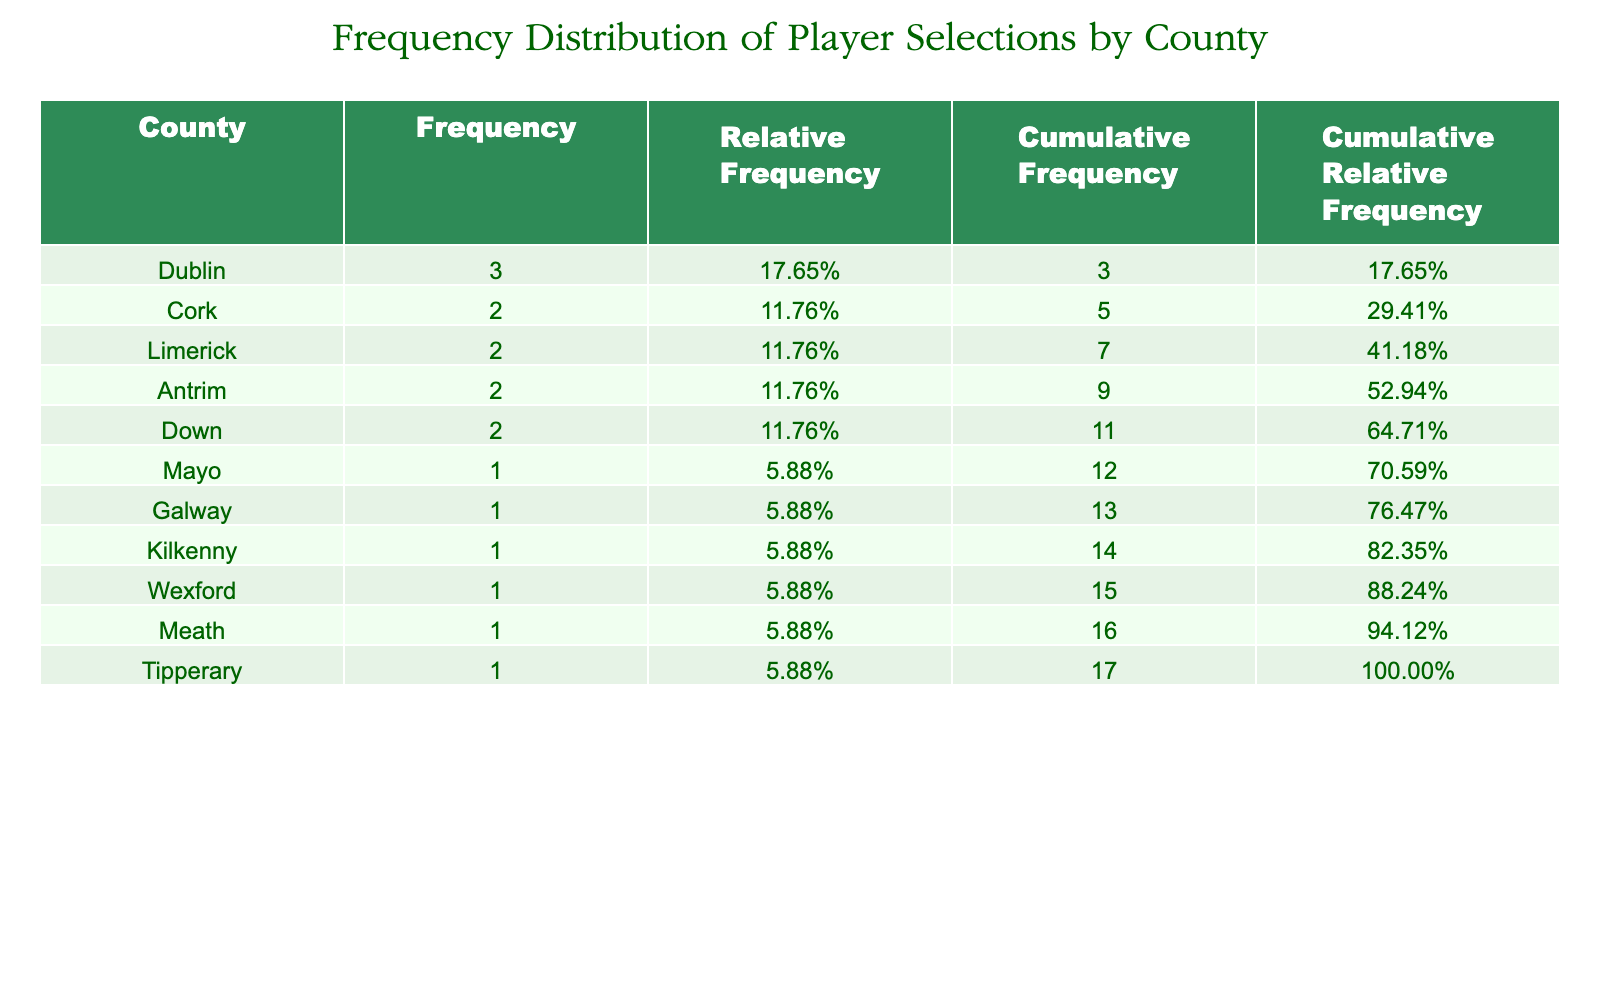What is the total number of selections for players from Dublin? From the table, the selections by players from Dublin are: Mark Adair (7), Andrew Balbirnie (8), and Stuart Poynter (5). Adding these numbers gives us 7 + 8 + 5 = 20.
Answer: 20 Which county has the highest frequency of player selections? Looking at the Frequency column in the table, Dublin has the highest frequency of selections with a total of 20.
Answer: Dublin Is there a player from Cork with more than 5 selections? In the table, Kevin O'Brien has 6 selections, which is more than 5. Therefore, the statement is true.
Answer: Yes What is the average number of selections for players from Limerick? The players' selections from Limerick are Peter Chase (3) and Barry McCarthy (5). To find the average: (3 + 5) / 2 = 4.
Answer: 4 How many counties have a frequency of player selections greater than 5? From the Frequency column, the counties with selections greater than 5 are Dublin and Cork (counties) and Tipperary (county). That's a total of 3 counties.
Answer: 3 What is the cumulative frequency of player selections for the county with the least selections? The county with the least selections is Mayo with only 1 selection. Since it is the only frequency count there, the cumulative frequency is 1.
Answer: 1 Are there any players selected from Down with more than 3 selections? The players from Down are Jacob Mulder (2) and Neil Rock (3). Both players do not have more than 3 selections, so the answer is false.
Answer: No What is the difference in selections between the highest and lowest selected player from Antrim? The players from Antrim are Shane Getkate (6) and Stuart Thompson (4). The difference is 6 - 4 = 2.
Answer: 2 Which player has the most selections from counties excluding Dublin and Cork? The player with the most selections outside Dublin and Cork is William Porterfield from Tipperary with 6 selections.
Answer: William Porterfield 